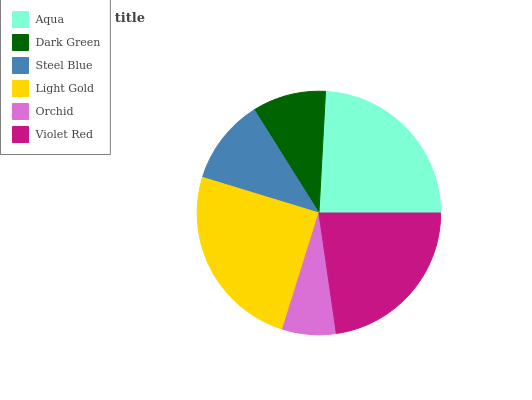Is Orchid the minimum?
Answer yes or no. Yes. Is Light Gold the maximum?
Answer yes or no. Yes. Is Dark Green the minimum?
Answer yes or no. No. Is Dark Green the maximum?
Answer yes or no. No. Is Aqua greater than Dark Green?
Answer yes or no. Yes. Is Dark Green less than Aqua?
Answer yes or no. Yes. Is Dark Green greater than Aqua?
Answer yes or no. No. Is Aqua less than Dark Green?
Answer yes or no. No. Is Violet Red the high median?
Answer yes or no. Yes. Is Steel Blue the low median?
Answer yes or no. Yes. Is Aqua the high median?
Answer yes or no. No. Is Violet Red the low median?
Answer yes or no. No. 